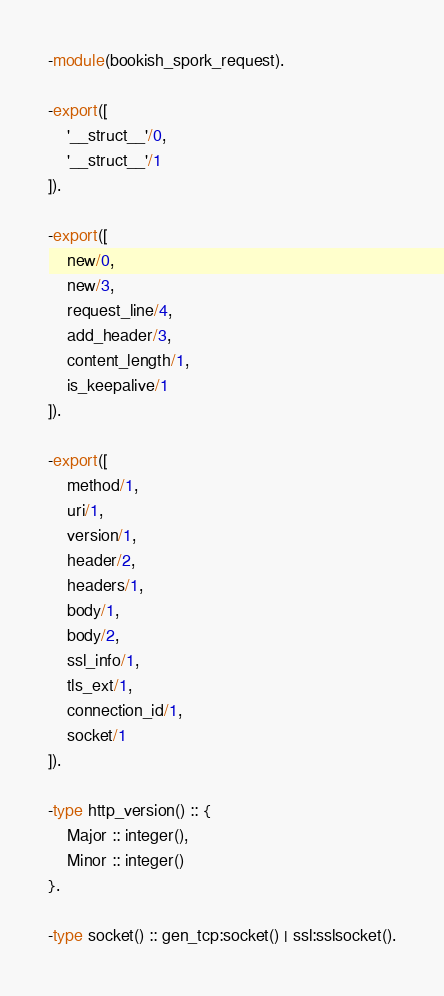Convert code to text. <code><loc_0><loc_0><loc_500><loc_500><_Erlang_>-module(bookish_spork_request).

-export([
    '__struct__'/0,
    '__struct__'/1
]).

-export([
    new/0,
    new/3,
    request_line/4,
    add_header/3,
    content_length/1,
    is_keepalive/1
]).

-export([
    method/1,
    uri/1,
    version/1,
    header/2,
    headers/1,
    body/1,
    body/2,
    ssl_info/1,
    tls_ext/1,
    connection_id/1,
    socket/1
]).

-type http_version() :: {
    Major :: integer(),
    Minor :: integer()
}.

-type socket() :: gen_tcp:socket() | ssl:sslsocket().
</code> 